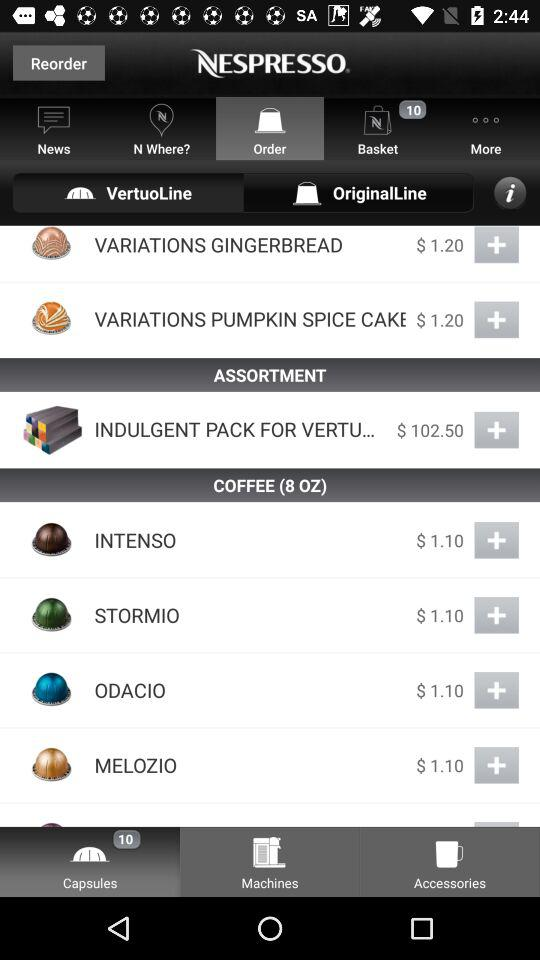Which tab is open? The open tabs are "Order", "Capsules" and "VertuoLine". 